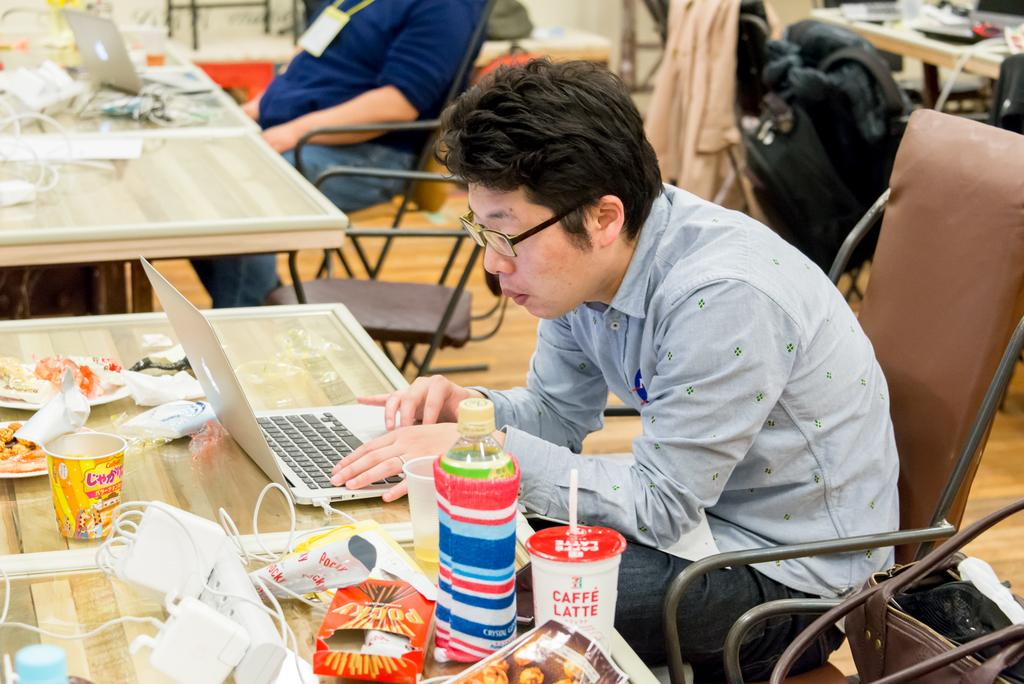How many people are in the image? There are two persons in the image. What are the two persons doing in the image? The two persons are sitting in front of a table. What objects can be seen on the table? There is a laptop, cups, plates, and bottles on the table. What type of spark can be seen coming from the pencil in the image? There is no pencil present in the image, so no spark can be observed. 